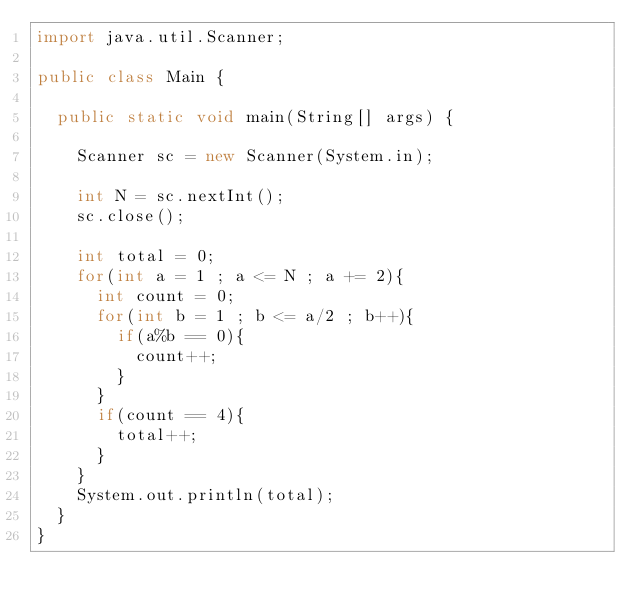Convert code to text. <code><loc_0><loc_0><loc_500><loc_500><_Java_>import java.util.Scanner;

public class Main {

	public static void main(String[] args) {
		
		Scanner sc = new Scanner(System.in);
		
		int N = sc.nextInt();
		sc.close();
		
		int total = 0;
		for(int a = 1 ; a <= N ; a += 2){
			int count = 0;
			for(int b = 1 ; b <= a/2 ; b++){
				if(a%b == 0){
					count++;
				}
			}
			if(count == 4){
				total++;
			}				
		}		
		System.out.println(total);
	}
}
</code> 